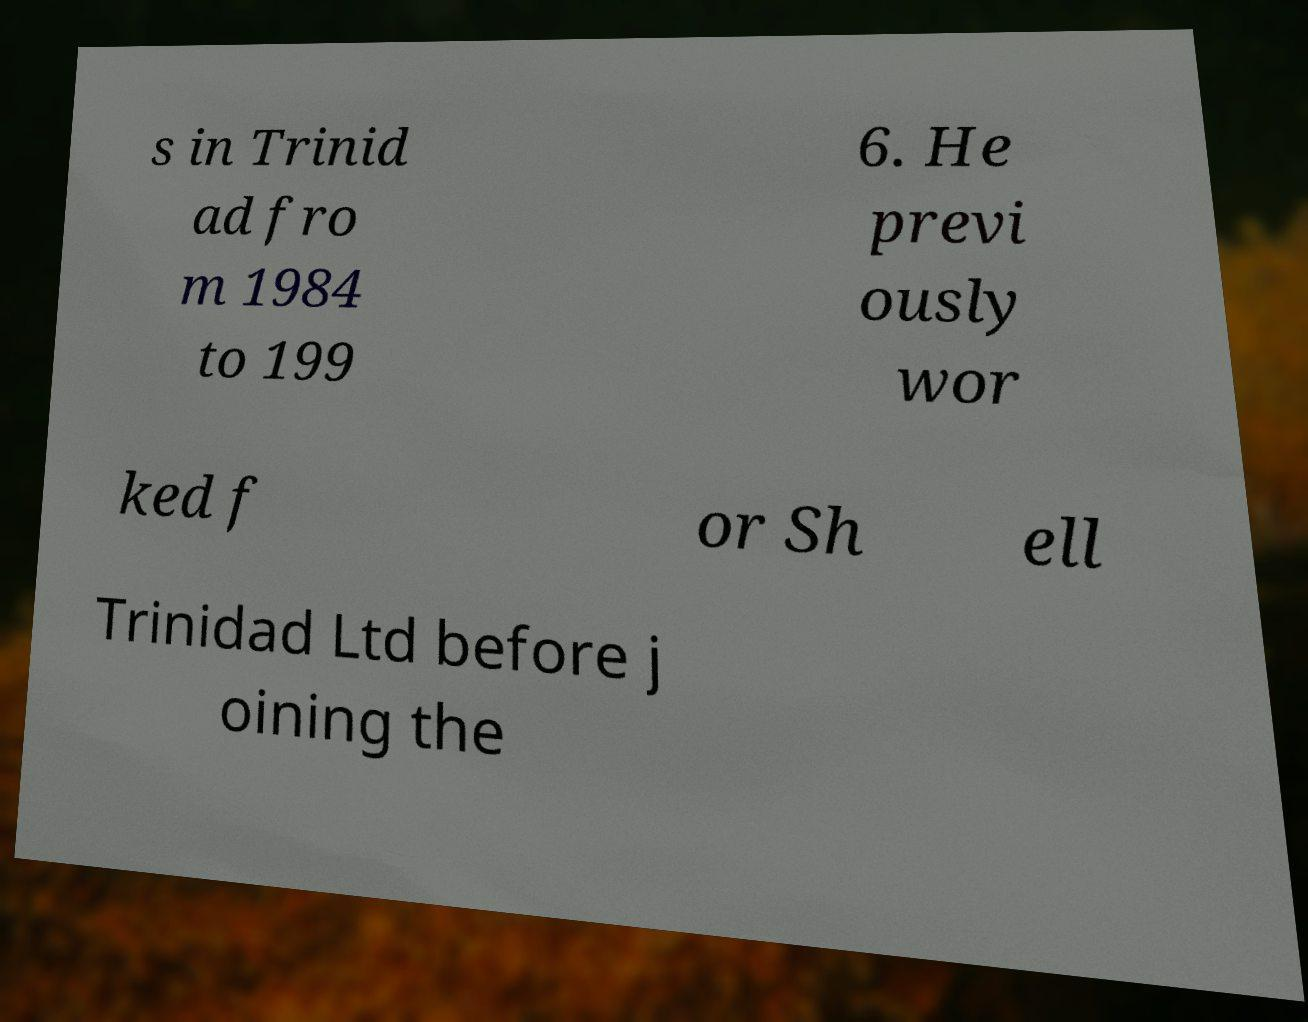Could you assist in decoding the text presented in this image and type it out clearly? s in Trinid ad fro m 1984 to 199 6. He previ ously wor ked f or Sh ell Trinidad Ltd before j oining the 